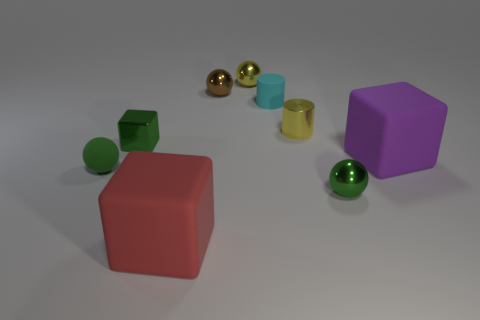Subtract all green matte spheres. How many spheres are left? 3 Subtract all brown spheres. How many spheres are left? 3 Add 1 small rubber cylinders. How many objects exist? 10 Subtract all balls. How many objects are left? 5 Subtract all purple balls. Subtract all brown blocks. How many balls are left? 4 Subtract 1 cubes. How many cubes are left? 2 Subtract all brown blocks. How many purple spheres are left? 0 Subtract all brown matte blocks. Subtract all small matte things. How many objects are left? 7 Add 8 purple rubber cubes. How many purple rubber cubes are left? 9 Add 5 tiny yellow shiny cylinders. How many tiny yellow shiny cylinders exist? 6 